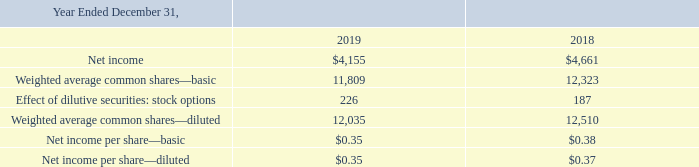Note 2: Net Income Per Share
Basic net income per share is computed using the weighted-average number of common shares outstanding for the period. Diluted net income per share is computed by adjusting the weighted-average number of common shares outstanding for the effect of dilutive potential common shares outstanding during the period. Potential common shares included in the diluted calculation consist of incremental shares issuable upon the exercise of outstanding stock options calculated using the treasury stock method.
The following table sets forth the calculation of basic and diluted net income per share (in thousands, except per share amounts):
For the years ended December 31, 2019 and 2018, options to purchase 200,000 and 200,000 shares of common stock, respectively, were not included in the computation of diluted net income per share because the effect would have been anti-dilutive.
What is the net income for 2019 and 2018 respectively?
Answer scale should be: thousand. $4,155, $4,661. How is basic net income per share computed? Using the weighted-average number of common shares outstanding for the period. How is diluted net income per share computed? Adjusting the weighted-average number of common shares outstanding for the effect of dilutive potential common shares outstanding during the period. What is the average basic net income per share for 2018 and 2019? (0.35+ 0.38)/2
Answer: 0.36. What is the change in net income between 2018 and 2019?
Answer scale should be: thousand. 4,155 -4,661 
Answer: -506. Which year has a higher amount of net income? Look at COL3 and COL4 , and compare the values of net income to determine the answer
Answer: 2018. 